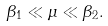Convert formula to latex. <formula><loc_0><loc_0><loc_500><loc_500>\beta _ { 1 } \ll \mu \ll \beta _ { 2 } .</formula> 